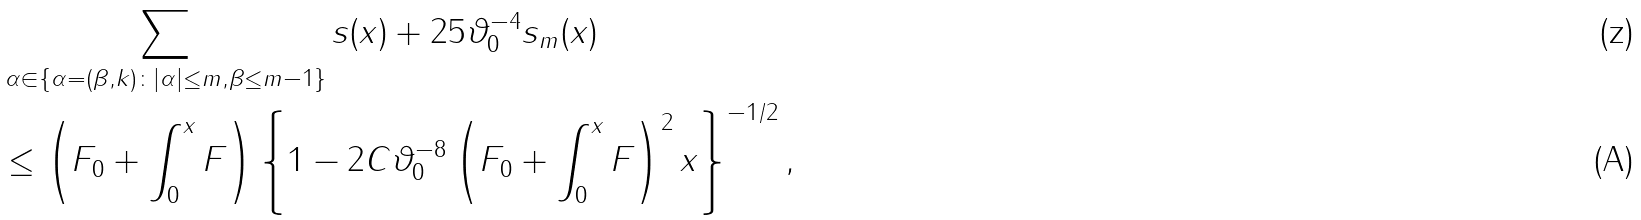Convert formula to latex. <formula><loc_0><loc_0><loc_500><loc_500>& \sum _ { \alpha \in \{ \alpha = ( \beta , k ) \colon | \alpha | \leq m , \beta \leq m - 1 \} } s ( x ) + 2 5 \vartheta _ { 0 } ^ { - 4 } s _ { m } ( x ) \\ & \leq \left ( F _ { 0 } + \int _ { 0 } ^ { x } F \right ) \left \{ 1 - 2 C \vartheta _ { 0 } ^ { - 8 } \left ( F _ { 0 } + \int _ { 0 } ^ { x } F \right ) ^ { 2 } x \right \} ^ { - 1 / 2 } ,</formula> 